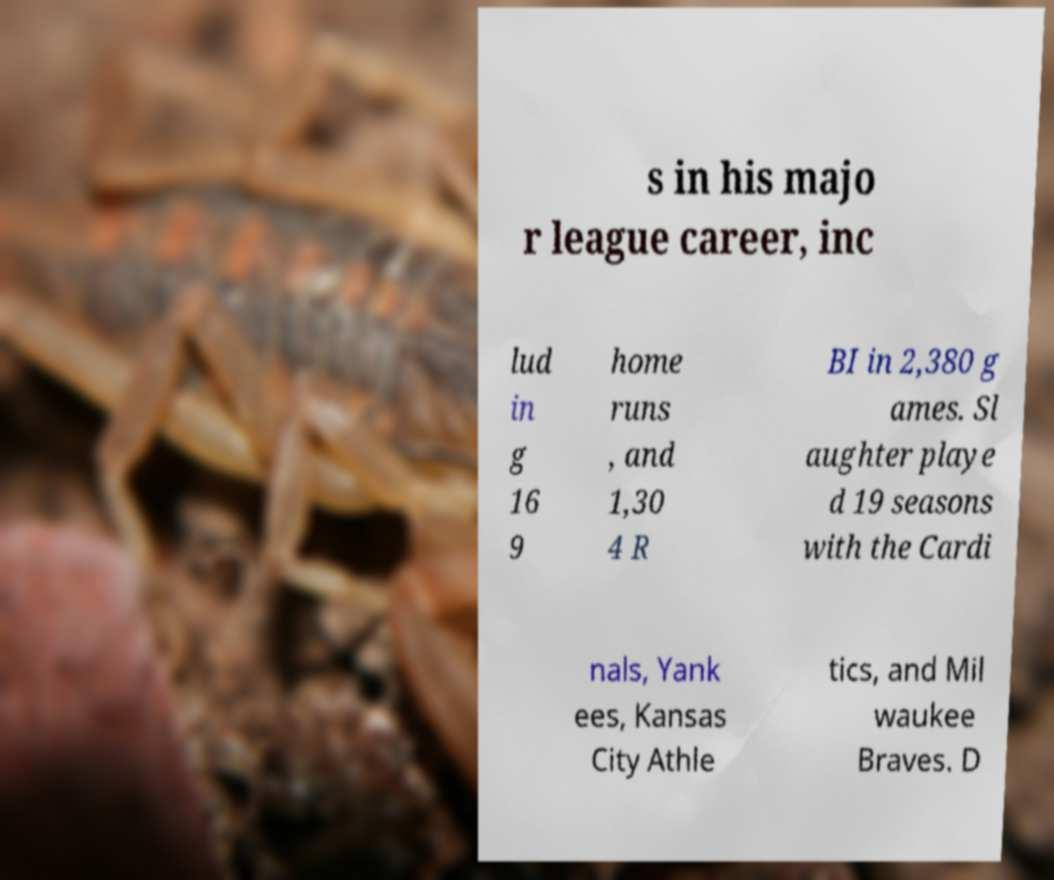Can you accurately transcribe the text from the provided image for me? s in his majo r league career, inc lud in g 16 9 home runs , and 1,30 4 R BI in 2,380 g ames. Sl aughter playe d 19 seasons with the Cardi nals, Yank ees, Kansas City Athle tics, and Mil waukee Braves. D 